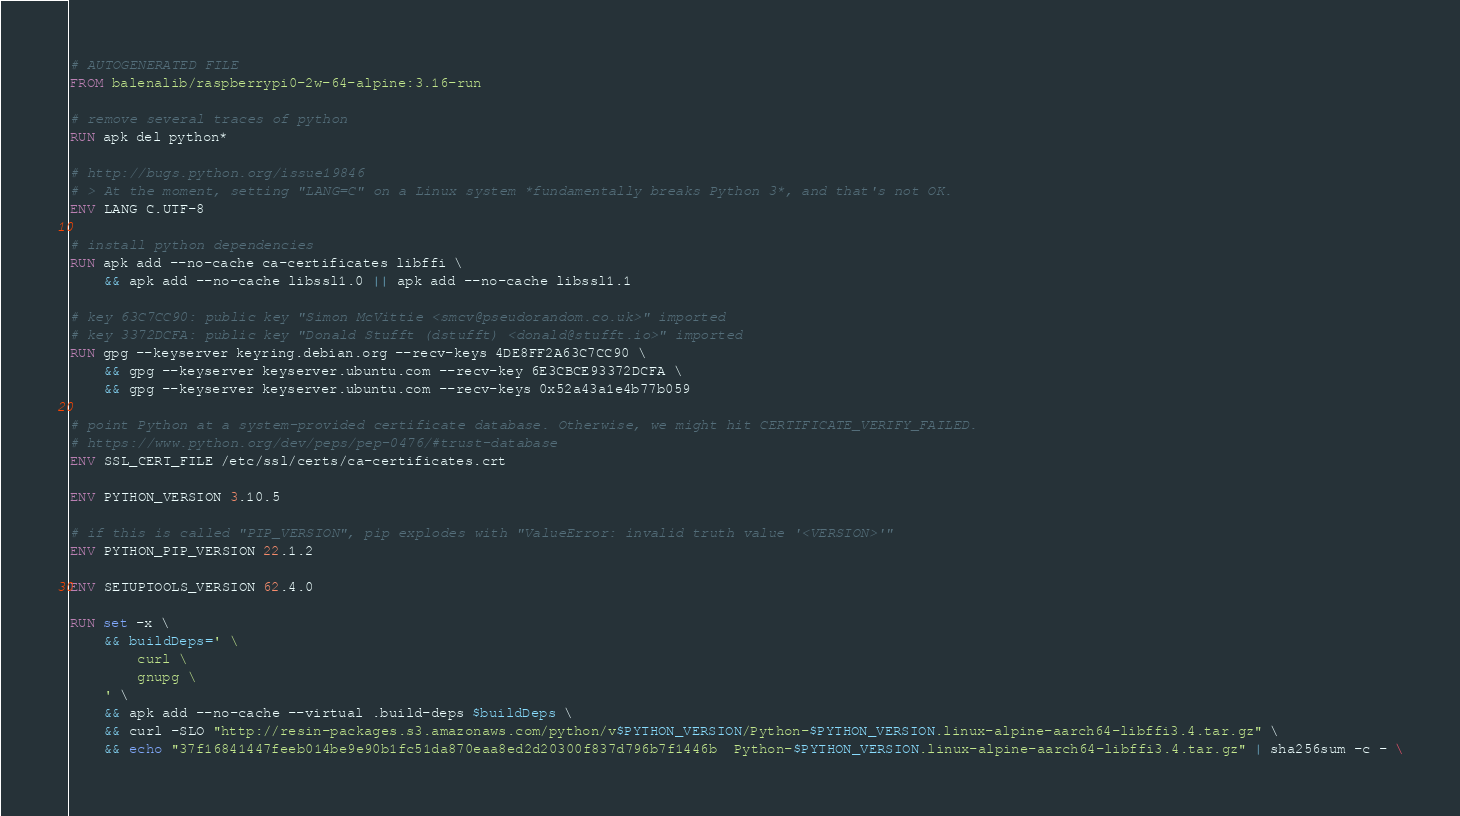<code> <loc_0><loc_0><loc_500><loc_500><_Dockerfile_># AUTOGENERATED FILE
FROM balenalib/raspberrypi0-2w-64-alpine:3.16-run

# remove several traces of python
RUN apk del python*

# http://bugs.python.org/issue19846
# > At the moment, setting "LANG=C" on a Linux system *fundamentally breaks Python 3*, and that's not OK.
ENV LANG C.UTF-8

# install python dependencies
RUN apk add --no-cache ca-certificates libffi \
	&& apk add --no-cache libssl1.0 || apk add --no-cache libssl1.1

# key 63C7CC90: public key "Simon McVittie <smcv@pseudorandom.co.uk>" imported
# key 3372DCFA: public key "Donald Stufft (dstufft) <donald@stufft.io>" imported
RUN gpg --keyserver keyring.debian.org --recv-keys 4DE8FF2A63C7CC90 \
	&& gpg --keyserver keyserver.ubuntu.com --recv-key 6E3CBCE93372DCFA \
	&& gpg --keyserver keyserver.ubuntu.com --recv-keys 0x52a43a1e4b77b059

# point Python at a system-provided certificate database. Otherwise, we might hit CERTIFICATE_VERIFY_FAILED.
# https://www.python.org/dev/peps/pep-0476/#trust-database
ENV SSL_CERT_FILE /etc/ssl/certs/ca-certificates.crt

ENV PYTHON_VERSION 3.10.5

# if this is called "PIP_VERSION", pip explodes with "ValueError: invalid truth value '<VERSION>'"
ENV PYTHON_PIP_VERSION 22.1.2

ENV SETUPTOOLS_VERSION 62.4.0

RUN set -x \
	&& buildDeps=' \
		curl \
		gnupg \
	' \
	&& apk add --no-cache --virtual .build-deps $buildDeps \
	&& curl -SLO "http://resin-packages.s3.amazonaws.com/python/v$PYTHON_VERSION/Python-$PYTHON_VERSION.linux-alpine-aarch64-libffi3.4.tar.gz" \
	&& echo "37f16841447feeb014be9e90b1fc51da870eaa8ed2d20300f837d796b7f1446b  Python-$PYTHON_VERSION.linux-alpine-aarch64-libffi3.4.tar.gz" | sha256sum -c - \</code> 